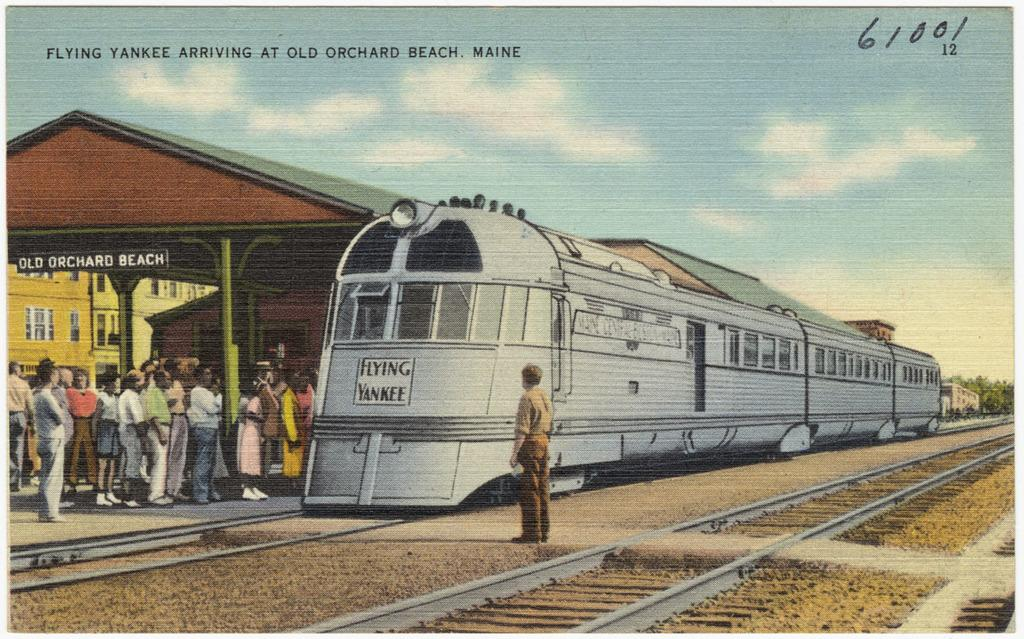<image>
Render a clear and concise summary of the photo. A post card of the Flying Yankee train  arriving at Orchard Beach Maine. 